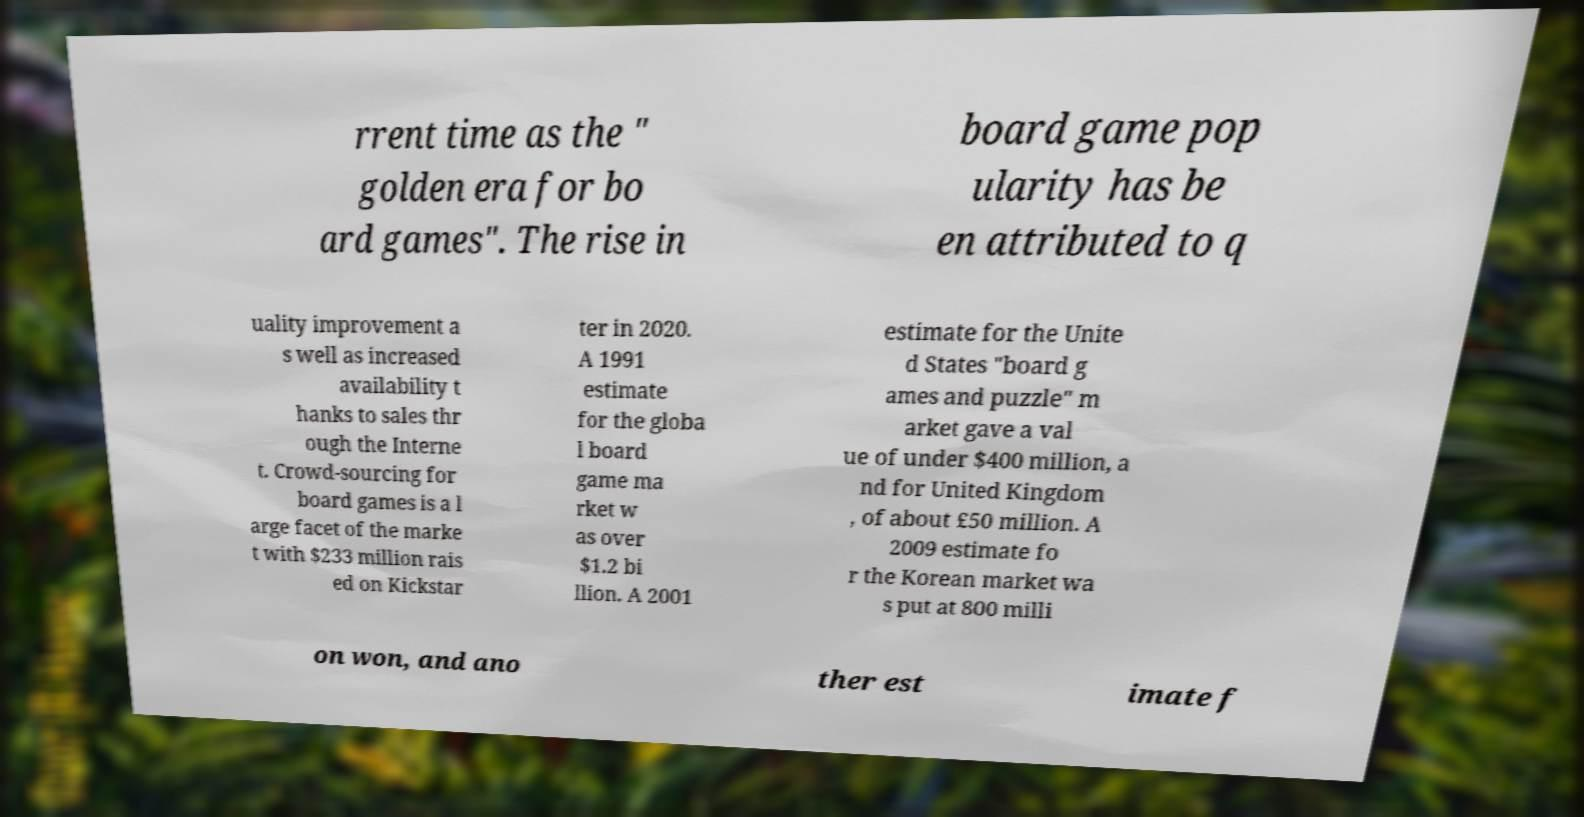Can you accurately transcribe the text from the provided image for me? rrent time as the " golden era for bo ard games". The rise in board game pop ularity has be en attributed to q uality improvement a s well as increased availability t hanks to sales thr ough the Interne t. Crowd-sourcing for board games is a l arge facet of the marke t with $233 million rais ed on Kickstar ter in 2020. A 1991 estimate for the globa l board game ma rket w as over $1.2 bi llion. A 2001 estimate for the Unite d States "board g ames and puzzle" m arket gave a val ue of under $400 million, a nd for United Kingdom , of about £50 million. A 2009 estimate fo r the Korean market wa s put at 800 milli on won, and ano ther est imate f 